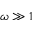Convert formula to latex. <formula><loc_0><loc_0><loc_500><loc_500>\omega \gg 1</formula> 